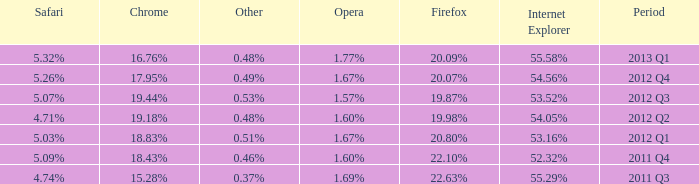What is the other that has 20.80% as the firefox? 0.51%. 